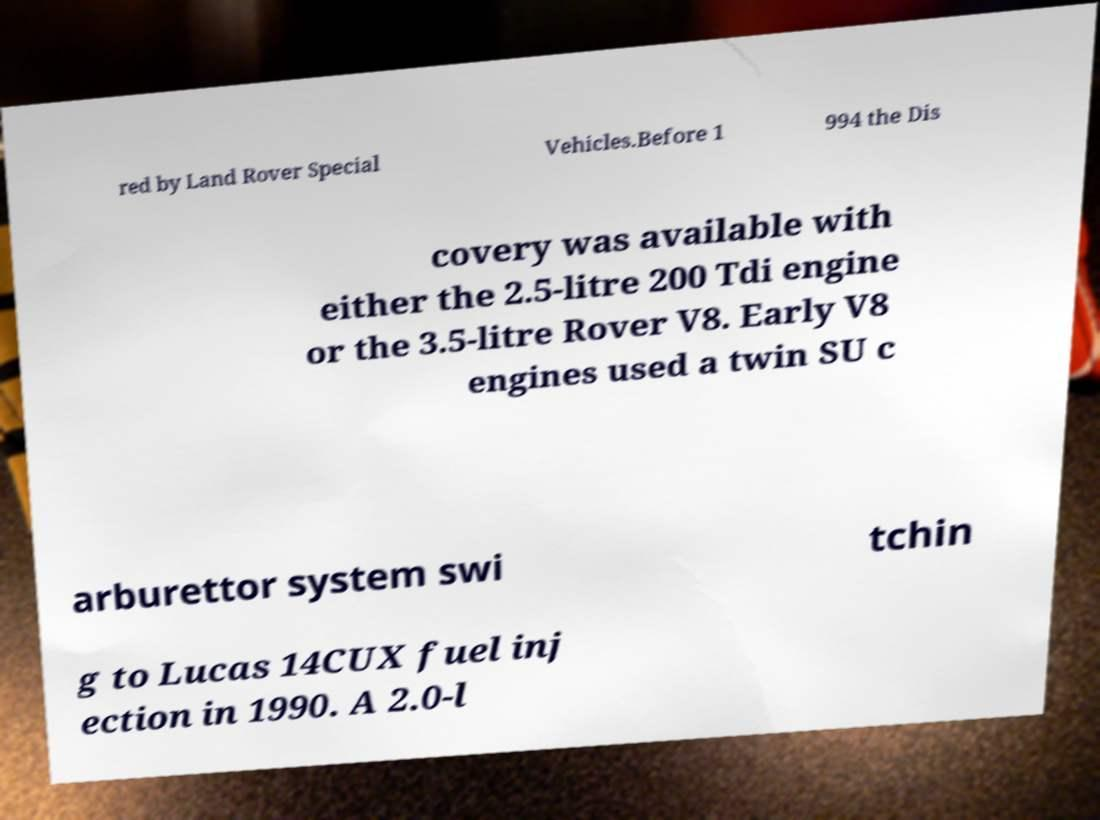For documentation purposes, I need the text within this image transcribed. Could you provide that? red by Land Rover Special Vehicles.Before 1 994 the Dis covery was available with either the 2.5-litre 200 Tdi engine or the 3.5-litre Rover V8. Early V8 engines used a twin SU c arburettor system swi tchin g to Lucas 14CUX fuel inj ection in 1990. A 2.0-l 